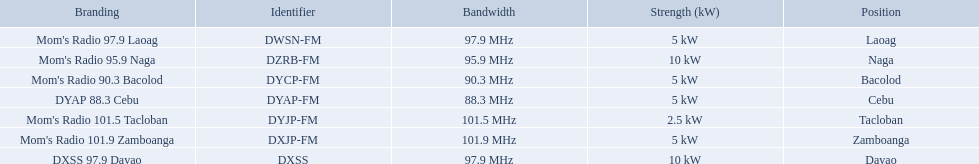What are all of the frequencies? 97.9 MHz, 95.9 MHz, 90.3 MHz, 88.3 MHz, 101.5 MHz, 101.9 MHz, 97.9 MHz. Which of these frequencies is the lowest? 88.3 MHz. Which branding does this frequency belong to? DYAP 88.3 Cebu. What brandings have a power of 5 kw? Mom's Radio 97.9 Laoag, Mom's Radio 90.3 Bacolod, DYAP 88.3 Cebu, Mom's Radio 101.9 Zamboanga. Which of these has a call-sign beginning with dy? Mom's Radio 90.3 Bacolod, DYAP 88.3 Cebu. Which of those uses the lowest frequency? DYAP 88.3 Cebu. 